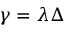<formula> <loc_0><loc_0><loc_500><loc_500>\gamma = \lambda \Delta</formula> 